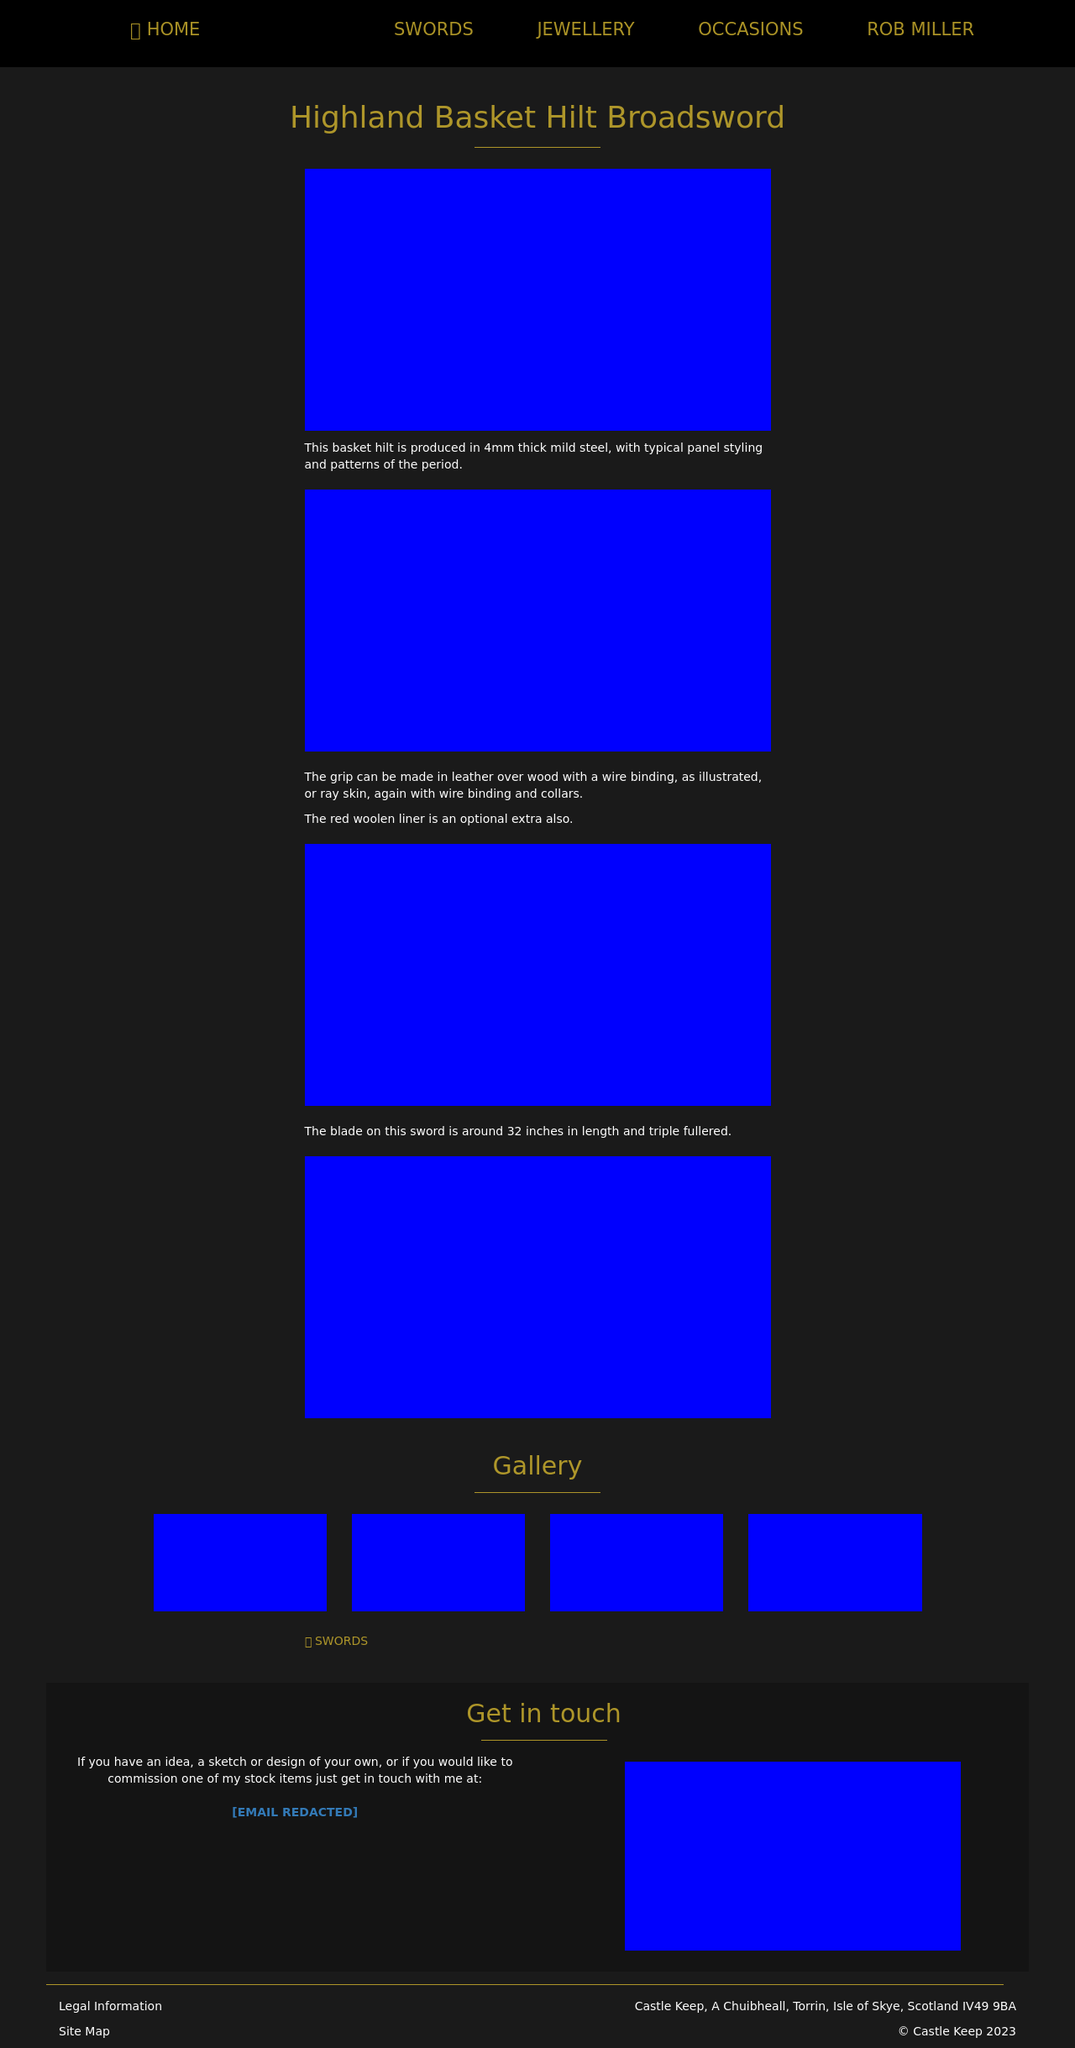Can you tell me more about the materials used in the production of swords represented in the image? Certainly! The swords typically illustrated here, such as the Highland Basket Hilt Broadsword, are crafted using a variety of high-quality materials. The blade is usually forged from carbon steel, known for its durability and sharpness. The hilt may be constructed from mild steel and often features intricate filigree work that could include precious metals for higher-ranked individuals. The grip might be covered in leather or rayskin, offering a sturdy yet comfortable hold, often adorned with wire binding to enhance the grip and overall aesthetic. 